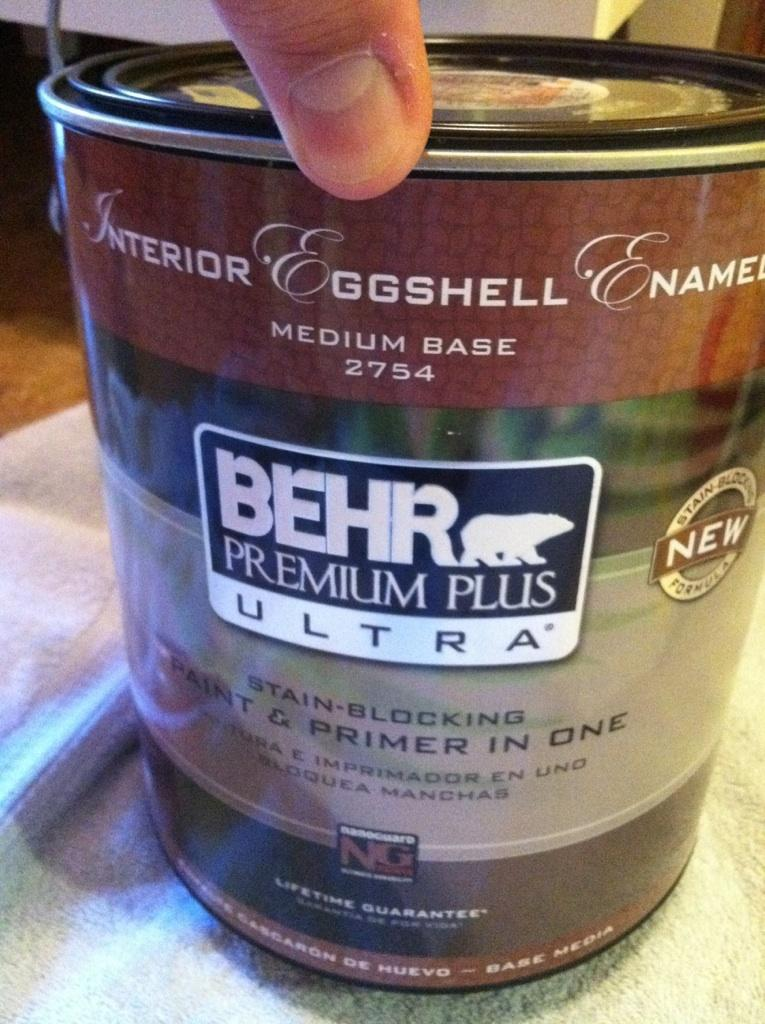What object is on the platform in the image? There is a tin on a platform in the image. Can you describe anything else visible on the platform? A person's finger is visible on the platform in the image. How does the visitor express their desire for the tin in the image? There is no visitor present in the image, and therefore no such interaction can be observed. What type of rod is being used by the person in the image? There is no rod visible in the image; only the tin and a person's finger are present. 